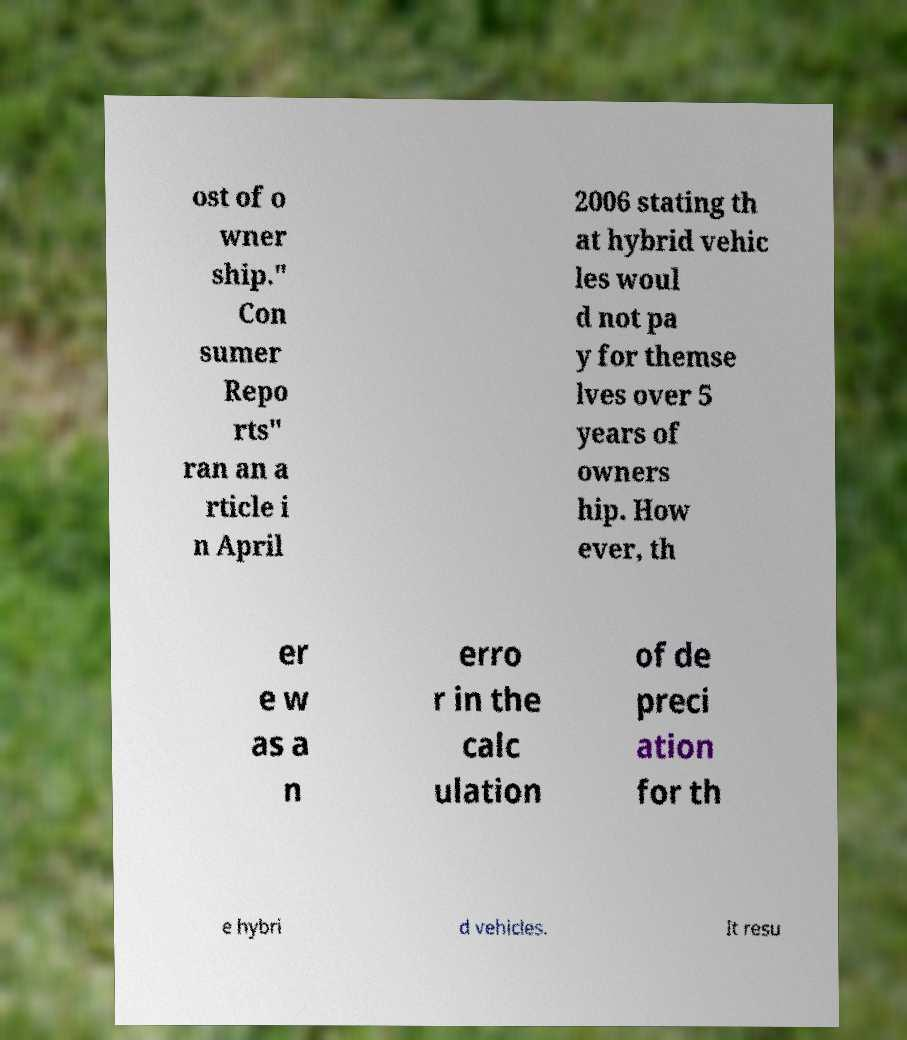For documentation purposes, I need the text within this image transcribed. Could you provide that? ost of o wner ship." Con sumer Repo rts" ran an a rticle i n April 2006 stating th at hybrid vehic les woul d not pa y for themse lves over 5 years of owners hip. How ever, th er e w as a n erro r in the calc ulation of de preci ation for th e hybri d vehicles. It resu 